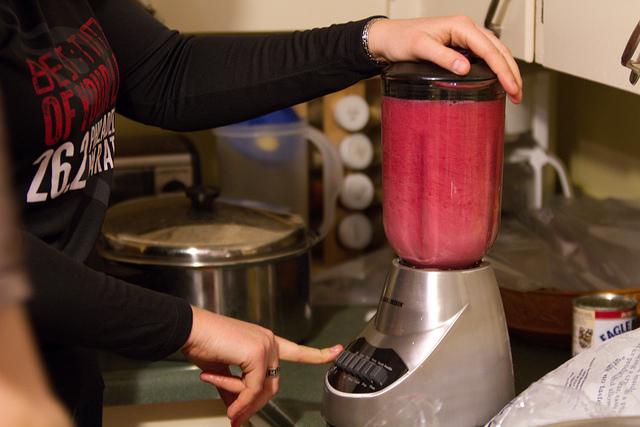What kitchen appliance is being used?
Give a very brief answer. Blender. Could this drink be frozen and sweet?
Give a very brief answer. Yes. Is this a commercial kitchen?
Write a very short answer. No. 